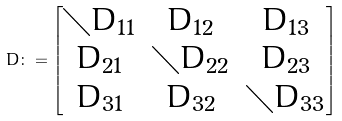<formula> <loc_0><loc_0><loc_500><loc_500>D \colon = \begin{bmatrix} { \diagdown } D _ { 1 1 } & D _ { 1 2 } & D _ { 1 3 } \\ D _ { 2 1 } & { \diagdown } D _ { 2 2 } & D _ { 2 3 } \\ D _ { 3 1 } & D _ { 3 2 } & { \diagdown } D _ { 3 3 } \end{bmatrix}</formula> 